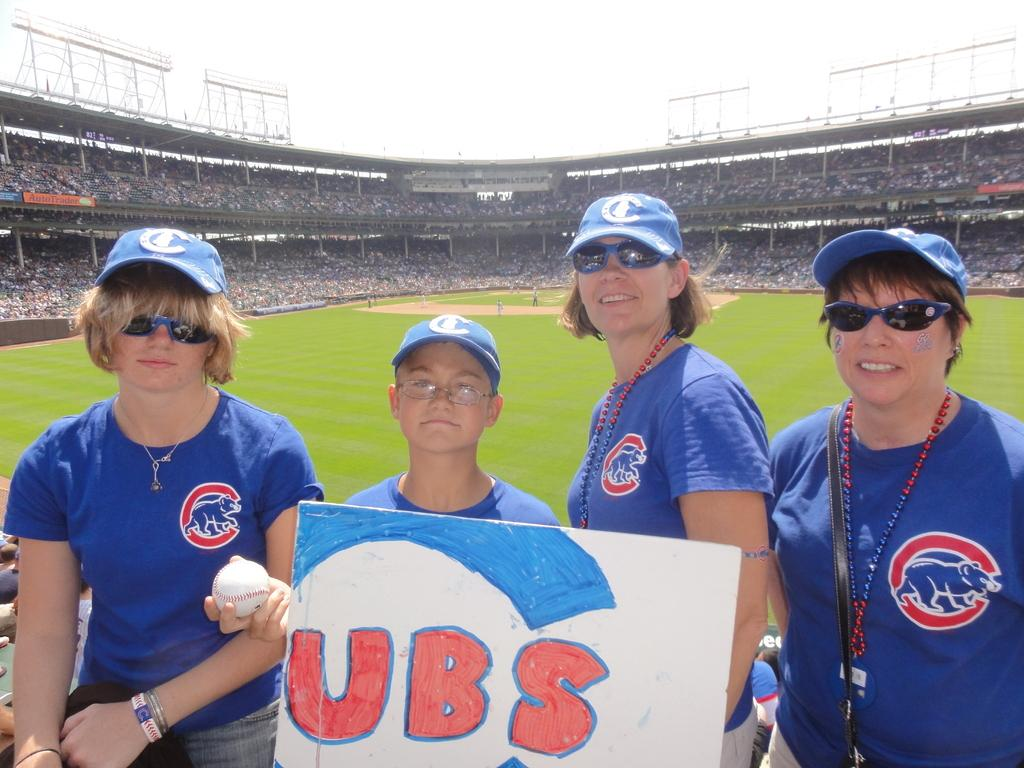Provide a one-sentence caption for the provided image. A boy wearing a blue hat holds a sign for the Cubs baseball team. 